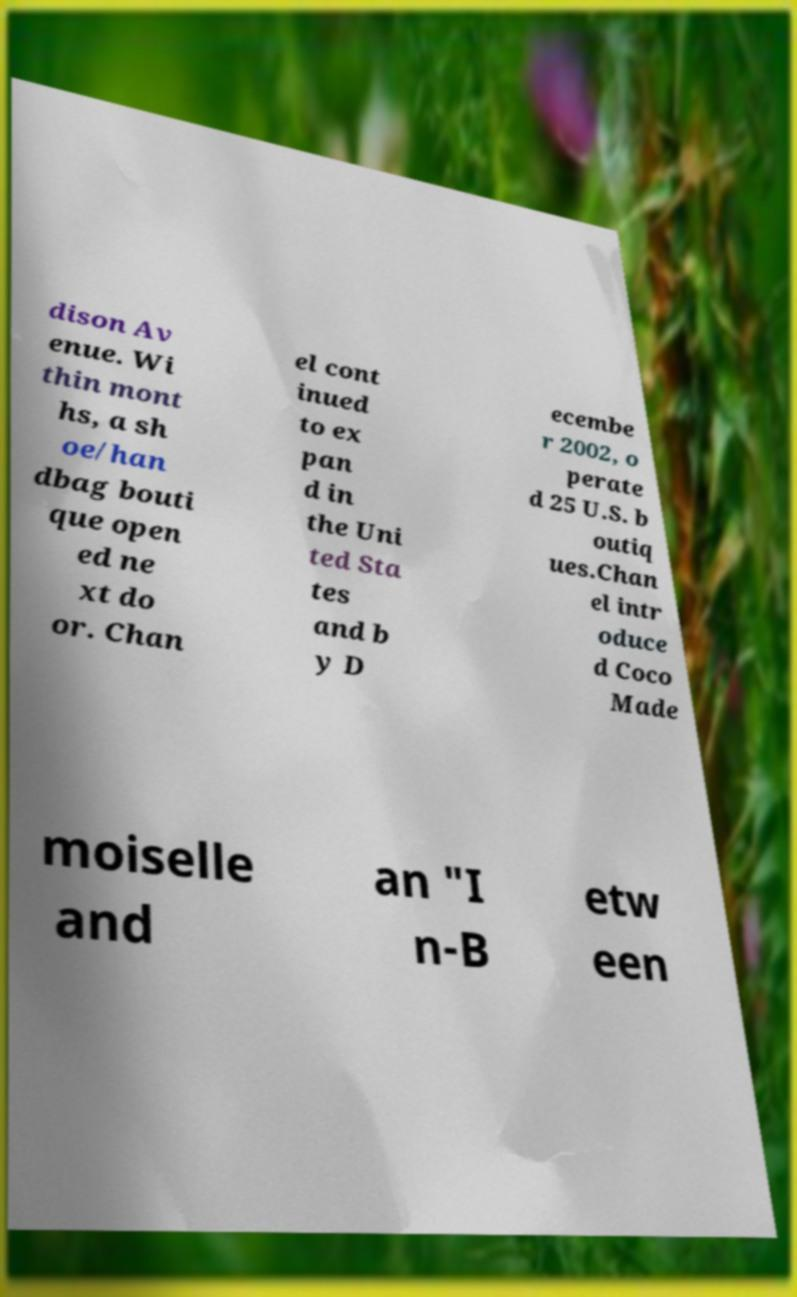For documentation purposes, I need the text within this image transcribed. Could you provide that? dison Av enue. Wi thin mont hs, a sh oe/han dbag bouti que open ed ne xt do or. Chan el cont inued to ex pan d in the Uni ted Sta tes and b y D ecembe r 2002, o perate d 25 U.S. b outiq ues.Chan el intr oduce d Coco Made moiselle and an "I n-B etw een 